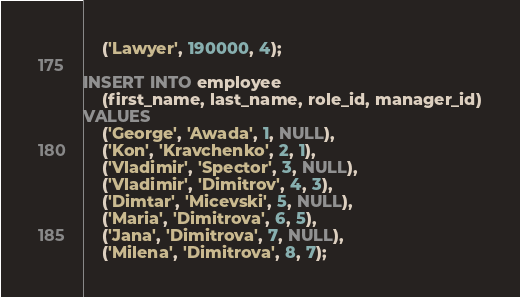Convert code to text. <code><loc_0><loc_0><loc_500><loc_500><_SQL_>    ('Lawyer', 190000, 4);

INSERT INTO employee
    (first_name, last_name, role_id, manager_id)
VALUES
    ('George', 'Awada', 1, NULL),
    ('Kon', 'Kravchenko', 2, 1),
    ('Vladimir', 'Spector', 3, NULL),
    ('Vladimir', 'Dimitrov', 4, 3),
    ('Dimtar', 'Micevski', 5, NULL),
    ('Maria', 'Dimitrova', 6, 5),
    ('Jana', 'Dimitrova', 7, NULL),
    ('Milena', 'Dimitrova', 8, 7);</code> 